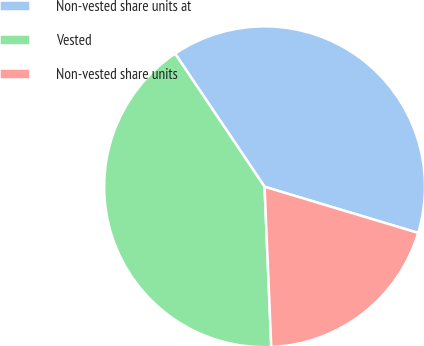<chart> <loc_0><loc_0><loc_500><loc_500><pie_chart><fcel>Non-vested share units at<fcel>Vested<fcel>Non-vested share units<nl><fcel>39.07%<fcel>41.25%<fcel>19.69%<nl></chart> 